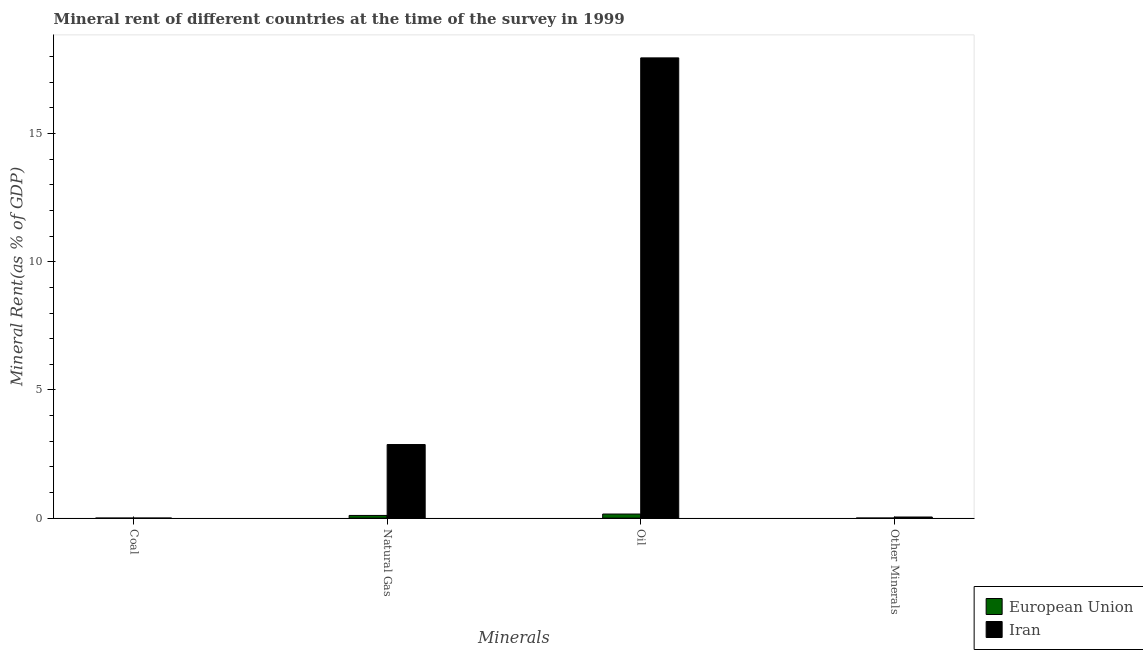How many different coloured bars are there?
Your answer should be compact. 2. How many groups of bars are there?
Offer a terse response. 4. Are the number of bars per tick equal to the number of legend labels?
Provide a succinct answer. Yes. Are the number of bars on each tick of the X-axis equal?
Ensure brevity in your answer.  Yes. How many bars are there on the 1st tick from the left?
Offer a terse response. 2. How many bars are there on the 1st tick from the right?
Your answer should be very brief. 2. What is the label of the 2nd group of bars from the left?
Provide a succinct answer. Natural Gas. What is the coal rent in Iran?
Your response must be concise. 0. Across all countries, what is the maximum  rent of other minerals?
Offer a very short reply. 0.04. Across all countries, what is the minimum coal rent?
Offer a terse response. 7.968829103317441e-5. In which country was the  rent of other minerals maximum?
Offer a very short reply. Iran. In which country was the  rent of other minerals minimum?
Offer a very short reply. European Union. What is the total natural gas rent in the graph?
Ensure brevity in your answer.  2.97. What is the difference between the natural gas rent in Iran and that in European Union?
Your answer should be compact. 2.77. What is the difference between the  rent of other minerals in European Union and the natural gas rent in Iran?
Your answer should be compact. -2.87. What is the average oil rent per country?
Offer a very short reply. 9.06. What is the difference between the coal rent and  rent of other minerals in European Union?
Provide a short and direct response. -0. In how many countries, is the  rent of other minerals greater than 9 %?
Offer a terse response. 0. What is the ratio of the natural gas rent in Iran to that in European Union?
Offer a very short reply. 27.48. What is the difference between the highest and the second highest coal rent?
Make the answer very short. 0. What is the difference between the highest and the lowest oil rent?
Make the answer very short. 17.79. Is the sum of the natural gas rent in European Union and Iran greater than the maximum coal rent across all countries?
Make the answer very short. Yes. What does the 1st bar from the left in Oil represents?
Ensure brevity in your answer.  European Union. What is the difference between two consecutive major ticks on the Y-axis?
Your answer should be compact. 5. Are the values on the major ticks of Y-axis written in scientific E-notation?
Give a very brief answer. No. Does the graph contain any zero values?
Provide a short and direct response. No. Does the graph contain grids?
Your answer should be very brief. No. Where does the legend appear in the graph?
Your response must be concise. Bottom right. How many legend labels are there?
Offer a terse response. 2. What is the title of the graph?
Your response must be concise. Mineral rent of different countries at the time of the survey in 1999. What is the label or title of the X-axis?
Make the answer very short. Minerals. What is the label or title of the Y-axis?
Keep it short and to the point. Mineral Rent(as % of GDP). What is the Mineral Rent(as % of GDP) of European Union in Coal?
Your answer should be compact. 7.968829103317441e-5. What is the Mineral Rent(as % of GDP) in Iran in Coal?
Your answer should be very brief. 0. What is the Mineral Rent(as % of GDP) in European Union in Natural Gas?
Your answer should be compact. 0.1. What is the Mineral Rent(as % of GDP) of Iran in Natural Gas?
Offer a very short reply. 2.87. What is the Mineral Rent(as % of GDP) in European Union in Oil?
Your answer should be compact. 0.16. What is the Mineral Rent(as % of GDP) of Iran in Oil?
Offer a very short reply. 17.95. What is the Mineral Rent(as % of GDP) in European Union in Other Minerals?
Offer a terse response. 0. What is the Mineral Rent(as % of GDP) in Iran in Other Minerals?
Make the answer very short. 0.04. Across all Minerals, what is the maximum Mineral Rent(as % of GDP) in European Union?
Your answer should be very brief. 0.16. Across all Minerals, what is the maximum Mineral Rent(as % of GDP) in Iran?
Provide a succinct answer. 17.95. Across all Minerals, what is the minimum Mineral Rent(as % of GDP) in European Union?
Your answer should be compact. 7.968829103317441e-5. Across all Minerals, what is the minimum Mineral Rent(as % of GDP) in Iran?
Provide a short and direct response. 0. What is the total Mineral Rent(as % of GDP) of European Union in the graph?
Your answer should be very brief. 0.27. What is the total Mineral Rent(as % of GDP) in Iran in the graph?
Provide a succinct answer. 20.87. What is the difference between the Mineral Rent(as % of GDP) of European Union in Coal and that in Natural Gas?
Give a very brief answer. -0.1. What is the difference between the Mineral Rent(as % of GDP) of Iran in Coal and that in Natural Gas?
Your answer should be compact. -2.87. What is the difference between the Mineral Rent(as % of GDP) in European Union in Coal and that in Oil?
Provide a short and direct response. -0.16. What is the difference between the Mineral Rent(as % of GDP) in Iran in Coal and that in Oil?
Give a very brief answer. -17.95. What is the difference between the Mineral Rent(as % of GDP) in European Union in Coal and that in Other Minerals?
Offer a terse response. -0. What is the difference between the Mineral Rent(as % of GDP) in Iran in Coal and that in Other Minerals?
Offer a very short reply. -0.04. What is the difference between the Mineral Rent(as % of GDP) in European Union in Natural Gas and that in Oil?
Provide a short and direct response. -0.05. What is the difference between the Mineral Rent(as % of GDP) of Iran in Natural Gas and that in Oil?
Your answer should be very brief. -15.08. What is the difference between the Mineral Rent(as % of GDP) in European Union in Natural Gas and that in Other Minerals?
Offer a terse response. 0.1. What is the difference between the Mineral Rent(as % of GDP) of Iran in Natural Gas and that in Other Minerals?
Ensure brevity in your answer.  2.83. What is the difference between the Mineral Rent(as % of GDP) of European Union in Oil and that in Other Minerals?
Provide a short and direct response. 0.16. What is the difference between the Mineral Rent(as % of GDP) in Iran in Oil and that in Other Minerals?
Provide a short and direct response. 17.91. What is the difference between the Mineral Rent(as % of GDP) in European Union in Coal and the Mineral Rent(as % of GDP) in Iran in Natural Gas?
Your response must be concise. -2.87. What is the difference between the Mineral Rent(as % of GDP) of European Union in Coal and the Mineral Rent(as % of GDP) of Iran in Oil?
Provide a succinct answer. -17.95. What is the difference between the Mineral Rent(as % of GDP) in European Union in Coal and the Mineral Rent(as % of GDP) in Iran in Other Minerals?
Your response must be concise. -0.04. What is the difference between the Mineral Rent(as % of GDP) in European Union in Natural Gas and the Mineral Rent(as % of GDP) in Iran in Oil?
Offer a very short reply. -17.85. What is the difference between the Mineral Rent(as % of GDP) in European Union in Natural Gas and the Mineral Rent(as % of GDP) in Iran in Other Minerals?
Offer a terse response. 0.06. What is the difference between the Mineral Rent(as % of GDP) of European Union in Oil and the Mineral Rent(as % of GDP) of Iran in Other Minerals?
Your answer should be very brief. 0.12. What is the average Mineral Rent(as % of GDP) in European Union per Minerals?
Offer a terse response. 0.07. What is the average Mineral Rent(as % of GDP) in Iran per Minerals?
Keep it short and to the point. 5.22. What is the difference between the Mineral Rent(as % of GDP) of European Union and Mineral Rent(as % of GDP) of Iran in Coal?
Your response must be concise. -0. What is the difference between the Mineral Rent(as % of GDP) in European Union and Mineral Rent(as % of GDP) in Iran in Natural Gas?
Make the answer very short. -2.77. What is the difference between the Mineral Rent(as % of GDP) in European Union and Mineral Rent(as % of GDP) in Iran in Oil?
Provide a short and direct response. -17.79. What is the difference between the Mineral Rent(as % of GDP) in European Union and Mineral Rent(as % of GDP) in Iran in Other Minerals?
Your answer should be very brief. -0.04. What is the ratio of the Mineral Rent(as % of GDP) in European Union in Coal to that in Natural Gas?
Your answer should be very brief. 0. What is the ratio of the Mineral Rent(as % of GDP) in European Union in Coal to that in Oil?
Offer a very short reply. 0. What is the ratio of the Mineral Rent(as % of GDP) in European Union in Coal to that in Other Minerals?
Provide a short and direct response. 0.03. What is the ratio of the Mineral Rent(as % of GDP) in Iran in Coal to that in Other Minerals?
Make the answer very short. 0.01. What is the ratio of the Mineral Rent(as % of GDP) in European Union in Natural Gas to that in Oil?
Ensure brevity in your answer.  0.66. What is the ratio of the Mineral Rent(as % of GDP) in Iran in Natural Gas to that in Oil?
Give a very brief answer. 0.16. What is the ratio of the Mineral Rent(as % of GDP) in European Union in Natural Gas to that in Other Minerals?
Ensure brevity in your answer.  40.79. What is the ratio of the Mineral Rent(as % of GDP) in Iran in Natural Gas to that in Other Minerals?
Your response must be concise. 66.56. What is the ratio of the Mineral Rent(as % of GDP) of European Union in Oil to that in Other Minerals?
Provide a short and direct response. 62.14. What is the ratio of the Mineral Rent(as % of GDP) in Iran in Oil to that in Other Minerals?
Make the answer very short. 416.33. What is the difference between the highest and the second highest Mineral Rent(as % of GDP) of European Union?
Provide a succinct answer. 0.05. What is the difference between the highest and the second highest Mineral Rent(as % of GDP) of Iran?
Give a very brief answer. 15.08. What is the difference between the highest and the lowest Mineral Rent(as % of GDP) of European Union?
Offer a very short reply. 0.16. What is the difference between the highest and the lowest Mineral Rent(as % of GDP) in Iran?
Offer a very short reply. 17.95. 